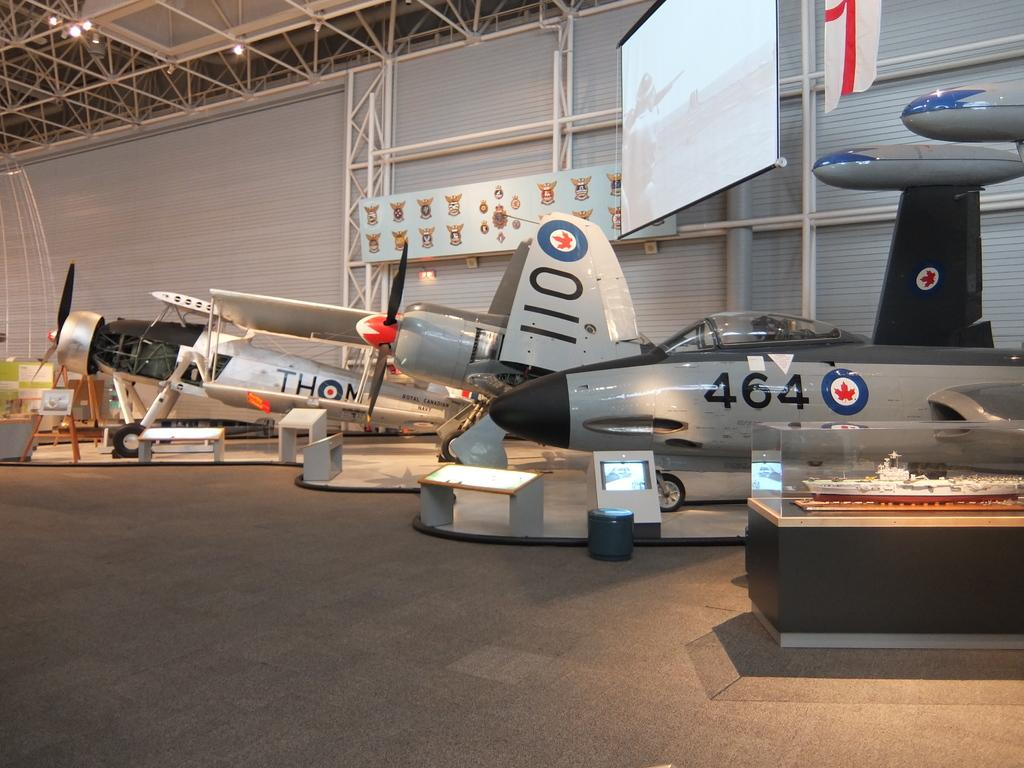What can be seen on the ground in the image? There are airplanes on the ground in the image. What is inside the glass box in the image? There is a toy ship inside the glass box in the image. What is hanging in the image? There is a banner in the image. What is present for displaying information or visuals in the image? There is a screen in the image. What can be seen in the distance in the image? There is a wall visible in the background of the image. What type of leather is used to make the airplane seats in the image? There is no information about airplane seats or leather in the image. The image only shows airplanes on the ground, a glass box with a toy ship, a banner, a screen, and a wall in the background. 